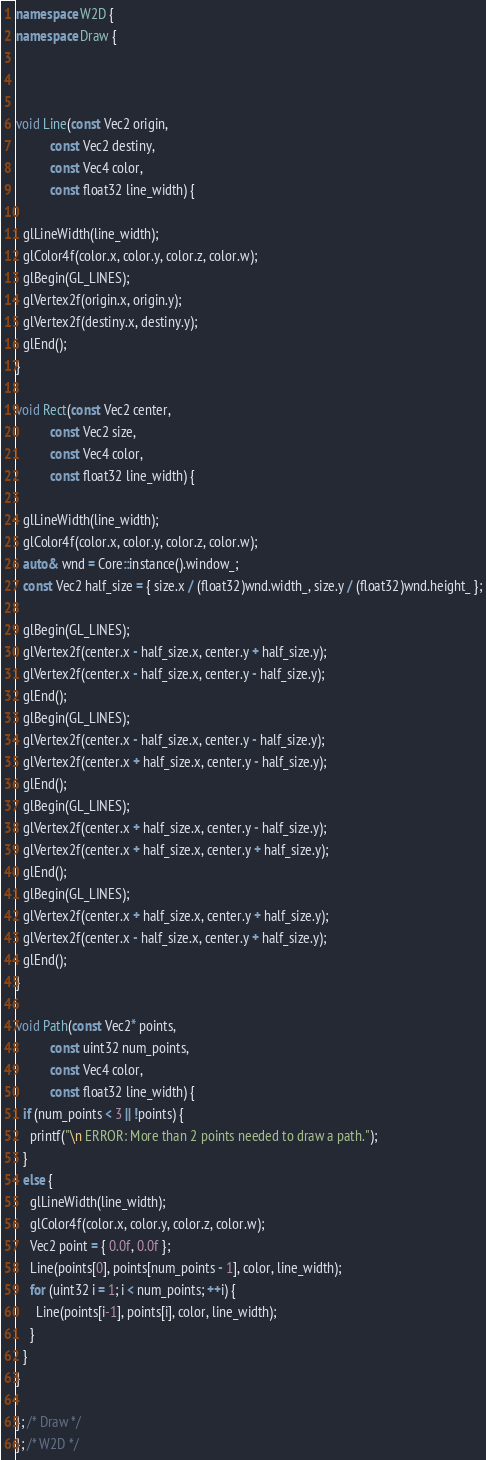Convert code to text. <code><loc_0><loc_0><loc_500><loc_500><_C++_>
namespace W2D {
namespace Draw {



void Line(const Vec2 origin, 
          const Vec2 destiny, 
          const Vec4 color, 
          const float32 line_width) {

  glLineWidth(line_width);
  glColor4f(color.x, color.y, color.z, color.w);
  glBegin(GL_LINES);
  glVertex2f(origin.x, origin.y);
  glVertex2f(destiny.x, destiny.y);
  glEnd();
}

void Rect(const Vec2 center, 
          const Vec2 size, 
          const Vec4 color, 
          const float32 line_width) {
  
  glLineWidth(line_width);
  glColor4f(color.x, color.y, color.z, color.w);
  auto& wnd = Core::instance().window_;
  const Vec2 half_size = { size.x / (float32)wnd.width_, size.y / (float32)wnd.height_ };

  glBegin(GL_LINES);
  glVertex2f(center.x - half_size.x, center.y + half_size.y);
  glVertex2f(center.x - half_size.x, center.y - half_size.y);
  glEnd();
  glBegin(GL_LINES);
  glVertex2f(center.x - half_size.x, center.y - half_size.y);
  glVertex2f(center.x + half_size.x, center.y - half_size.y);
  glEnd();
  glBegin(GL_LINES);
  glVertex2f(center.x + half_size.x, center.y - half_size.y);
  glVertex2f(center.x + half_size.x, center.y + half_size.y);
  glEnd();
  glBegin(GL_LINES);
  glVertex2f(center.x + half_size.x, center.y + half_size.y);
  glVertex2f(center.x - half_size.x, center.y + half_size.y);
  glEnd();
}

void Path(const Vec2* points, 
          const uint32 num_points, 
          const Vec4 color, 
          const float32 line_width) {
  if (num_points < 3 || !points) {
    printf("\n ERROR: More than 2 points needed to draw a path.");
  }
  else {
    glLineWidth(line_width);
    glColor4f(color.x, color.y, color.z, color.w);
    Vec2 point = { 0.0f, 0.0f };
    Line(points[0], points[num_points - 1], color, line_width);
    for (uint32 i = 1; i < num_points; ++i) {
      Line(points[i-1], points[i], color, line_width);
    }
  }
}

}; /* Draw */
}; /* W2D */
</code> 